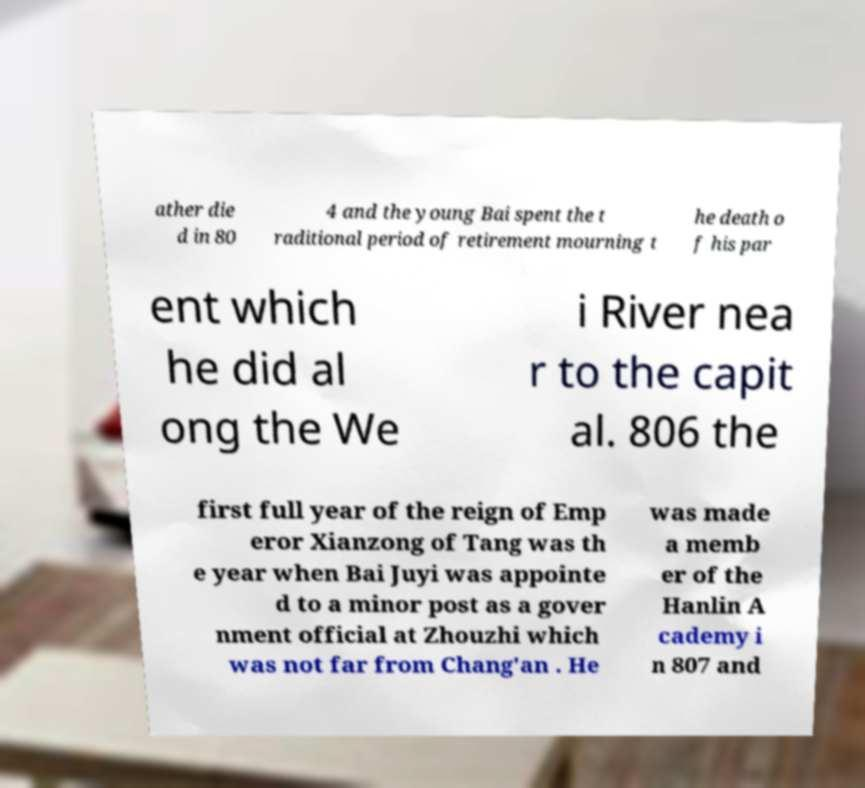Can you read and provide the text displayed in the image?This photo seems to have some interesting text. Can you extract and type it out for me? ather die d in 80 4 and the young Bai spent the t raditional period of retirement mourning t he death o f his par ent which he did al ong the We i River nea r to the capit al. 806 the first full year of the reign of Emp eror Xianzong of Tang was th e year when Bai Juyi was appointe d to a minor post as a gover nment official at Zhouzhi which was not far from Chang'an . He was made a memb er of the Hanlin A cademy i n 807 and 